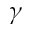Convert formula to latex. <formula><loc_0><loc_0><loc_500><loc_500>\gamma</formula> 